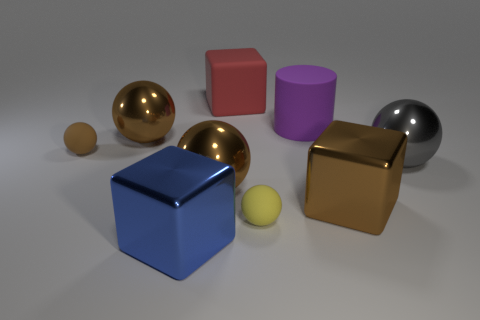Subtract all yellow cylinders. How many brown balls are left? 3 Subtract all gray spheres. How many spheres are left? 4 Subtract all yellow balls. How many balls are left? 4 Subtract all purple balls. Subtract all green blocks. How many balls are left? 5 Add 1 big cyan cylinders. How many objects exist? 10 Subtract all spheres. How many objects are left? 4 Subtract 1 brown cubes. How many objects are left? 8 Subtract all big gray cubes. Subtract all blocks. How many objects are left? 6 Add 2 large blocks. How many large blocks are left? 5 Add 8 blue metal blocks. How many blue metal blocks exist? 9 